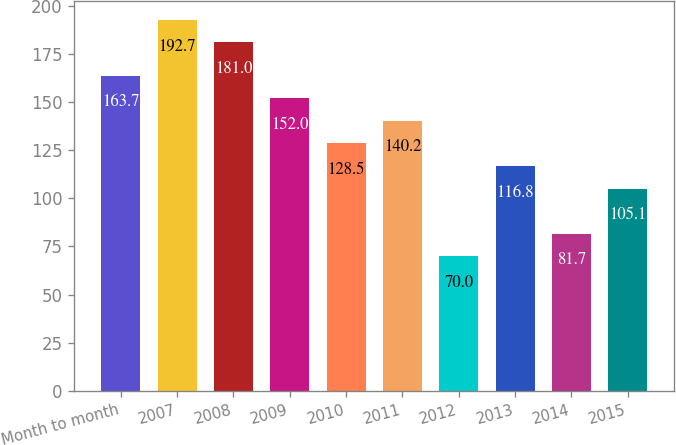Convert chart. <chart><loc_0><loc_0><loc_500><loc_500><bar_chart><fcel>Month to month<fcel>2007<fcel>2008<fcel>2009<fcel>2010<fcel>2011<fcel>2012<fcel>2013<fcel>2014<fcel>2015<nl><fcel>163.7<fcel>192.7<fcel>181<fcel>152<fcel>128.5<fcel>140.2<fcel>70<fcel>116.8<fcel>81.7<fcel>105.1<nl></chart> 